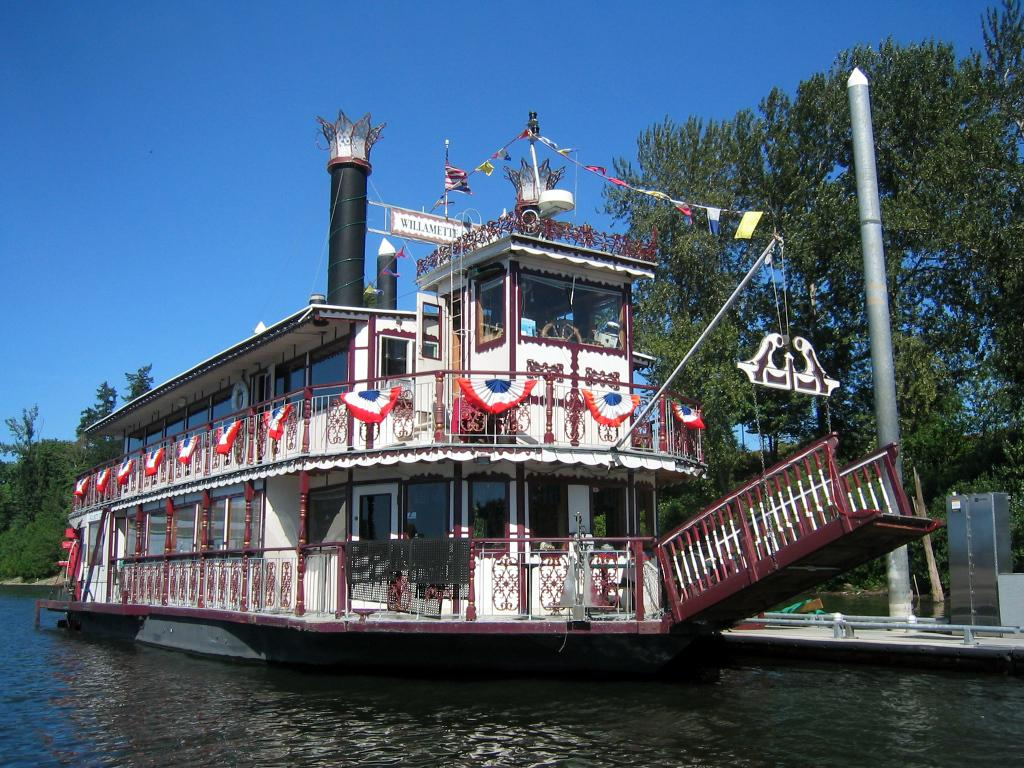What is the main subject of the image? The main subject of the image is a boat. Where is the boat located? The boat is on the water. What can be seen in the background of the image? There are trees visible in the image. What color is the sky in the image? The sky is blue in the image. What type of pancake is being used to cause a connection between the boat and the trees in the image? There is no pancake present in the image, nor is there any indication of a connection being made between the boat and the trees. 